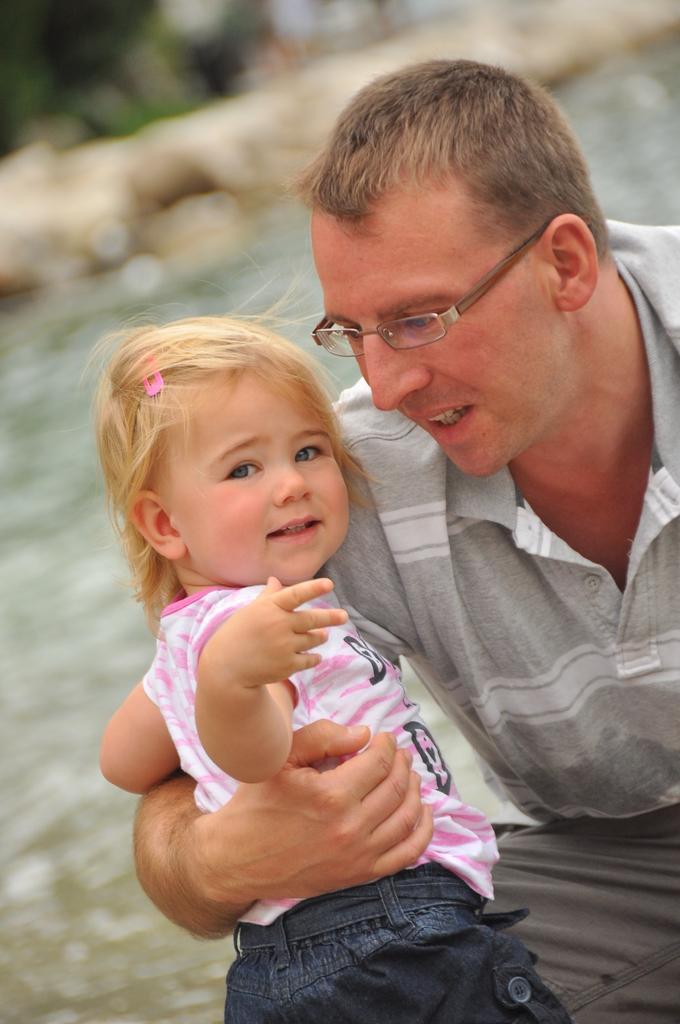In one or two sentences, can you explain what this image depicts? In this image I can see a man is holding a girl. The man is wearing spectacles, t-shirt and pant. The background of the image is blurred. 